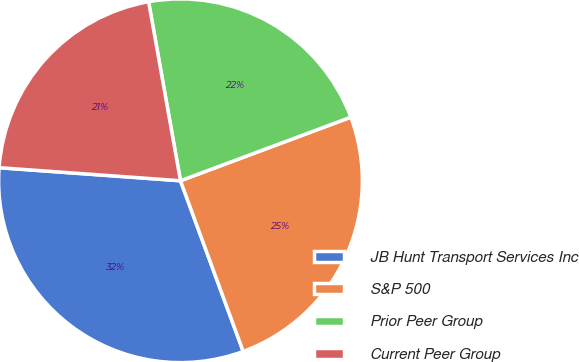Convert chart to OTSL. <chart><loc_0><loc_0><loc_500><loc_500><pie_chart><fcel>JB Hunt Transport Services Inc<fcel>S&P 500<fcel>Prior Peer Group<fcel>Current Peer Group<nl><fcel>31.75%<fcel>25.08%<fcel>22.12%<fcel>21.05%<nl></chart> 